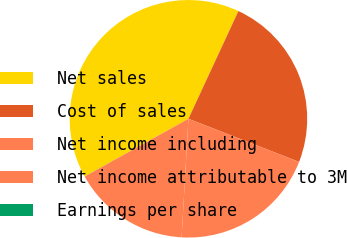Convert chart. <chart><loc_0><loc_0><loc_500><loc_500><pie_chart><fcel>Net sales<fcel>Cost of sales<fcel>Net income including<fcel>Net income attributable to 3M<fcel>Earnings per share<nl><fcel>39.99%<fcel>24.0%<fcel>20.0%<fcel>16.0%<fcel>0.01%<nl></chart> 